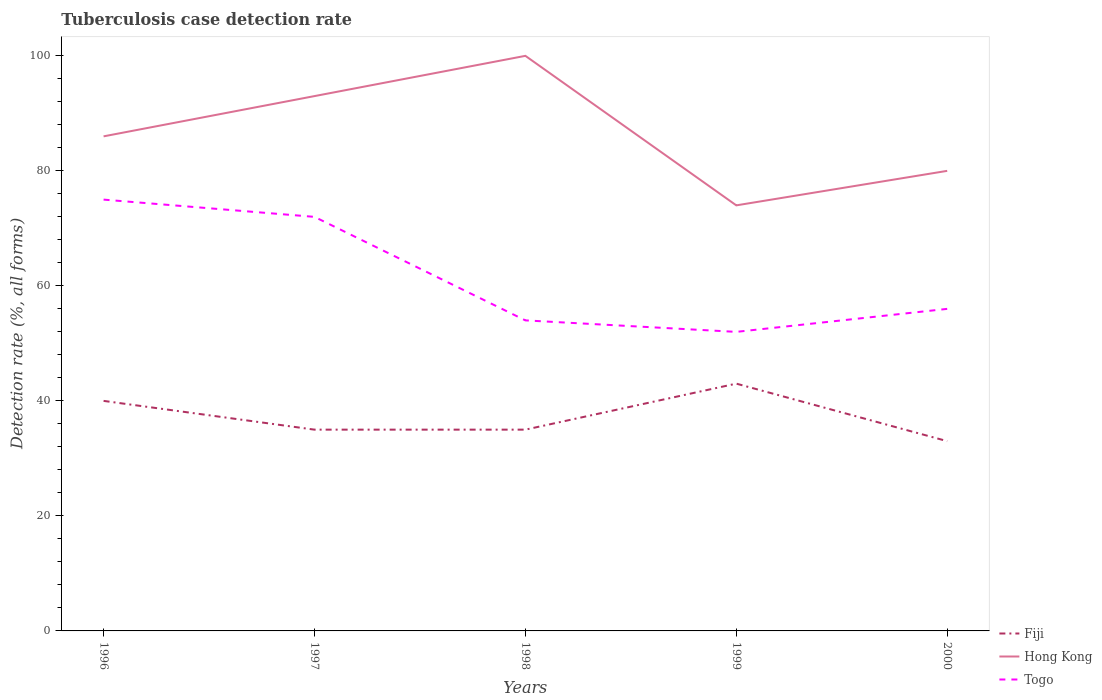How many different coloured lines are there?
Give a very brief answer. 3. Across all years, what is the maximum tuberculosis case detection rate in in Fiji?
Your answer should be very brief. 33. What is the difference between the highest and the lowest tuberculosis case detection rate in in Fiji?
Your answer should be compact. 2. Is the tuberculosis case detection rate in in Togo strictly greater than the tuberculosis case detection rate in in Hong Kong over the years?
Offer a very short reply. Yes. Are the values on the major ticks of Y-axis written in scientific E-notation?
Your answer should be very brief. No. Does the graph contain any zero values?
Your answer should be compact. No. Does the graph contain grids?
Offer a terse response. No. Where does the legend appear in the graph?
Ensure brevity in your answer.  Bottom right. What is the title of the graph?
Offer a terse response. Tuberculosis case detection rate. What is the label or title of the Y-axis?
Ensure brevity in your answer.  Detection rate (%, all forms). What is the Detection rate (%, all forms) in Hong Kong in 1996?
Your answer should be compact. 86. What is the Detection rate (%, all forms) in Fiji in 1997?
Offer a very short reply. 35. What is the Detection rate (%, all forms) in Hong Kong in 1997?
Your response must be concise. 93. What is the Detection rate (%, all forms) in Togo in 1997?
Your response must be concise. 72. What is the Detection rate (%, all forms) in Togo in 1999?
Keep it short and to the point. 52. What is the Detection rate (%, all forms) of Togo in 2000?
Provide a succinct answer. 56. Across all years, what is the maximum Detection rate (%, all forms) of Togo?
Offer a terse response. 75. Across all years, what is the minimum Detection rate (%, all forms) of Fiji?
Give a very brief answer. 33. Across all years, what is the minimum Detection rate (%, all forms) in Hong Kong?
Offer a terse response. 74. Across all years, what is the minimum Detection rate (%, all forms) in Togo?
Your response must be concise. 52. What is the total Detection rate (%, all forms) in Fiji in the graph?
Your answer should be compact. 186. What is the total Detection rate (%, all forms) of Hong Kong in the graph?
Keep it short and to the point. 433. What is the total Detection rate (%, all forms) in Togo in the graph?
Your answer should be very brief. 309. What is the difference between the Detection rate (%, all forms) in Fiji in 1996 and that in 1998?
Offer a terse response. 5. What is the difference between the Detection rate (%, all forms) in Hong Kong in 1996 and that in 1998?
Ensure brevity in your answer.  -14. What is the difference between the Detection rate (%, all forms) in Fiji in 1996 and that in 2000?
Provide a short and direct response. 7. What is the difference between the Detection rate (%, all forms) of Hong Kong in 1997 and that in 1998?
Provide a short and direct response. -7. What is the difference between the Detection rate (%, all forms) in Hong Kong in 1997 and that in 1999?
Your response must be concise. 19. What is the difference between the Detection rate (%, all forms) in Hong Kong in 1998 and that in 1999?
Your response must be concise. 26. What is the difference between the Detection rate (%, all forms) in Fiji in 1998 and that in 2000?
Your answer should be compact. 2. What is the difference between the Detection rate (%, all forms) in Hong Kong in 1998 and that in 2000?
Your answer should be compact. 20. What is the difference between the Detection rate (%, all forms) of Togo in 1999 and that in 2000?
Your response must be concise. -4. What is the difference between the Detection rate (%, all forms) of Fiji in 1996 and the Detection rate (%, all forms) of Hong Kong in 1997?
Your answer should be very brief. -53. What is the difference between the Detection rate (%, all forms) of Fiji in 1996 and the Detection rate (%, all forms) of Togo in 1997?
Provide a short and direct response. -32. What is the difference between the Detection rate (%, all forms) in Hong Kong in 1996 and the Detection rate (%, all forms) in Togo in 1997?
Provide a short and direct response. 14. What is the difference between the Detection rate (%, all forms) in Fiji in 1996 and the Detection rate (%, all forms) in Hong Kong in 1998?
Offer a very short reply. -60. What is the difference between the Detection rate (%, all forms) of Fiji in 1996 and the Detection rate (%, all forms) of Hong Kong in 1999?
Give a very brief answer. -34. What is the difference between the Detection rate (%, all forms) of Fiji in 1996 and the Detection rate (%, all forms) of Togo in 1999?
Provide a short and direct response. -12. What is the difference between the Detection rate (%, all forms) in Fiji in 1996 and the Detection rate (%, all forms) in Togo in 2000?
Offer a terse response. -16. What is the difference between the Detection rate (%, all forms) of Hong Kong in 1996 and the Detection rate (%, all forms) of Togo in 2000?
Provide a short and direct response. 30. What is the difference between the Detection rate (%, all forms) of Fiji in 1997 and the Detection rate (%, all forms) of Hong Kong in 1998?
Your response must be concise. -65. What is the difference between the Detection rate (%, all forms) of Fiji in 1997 and the Detection rate (%, all forms) of Togo in 1998?
Your response must be concise. -19. What is the difference between the Detection rate (%, all forms) of Hong Kong in 1997 and the Detection rate (%, all forms) of Togo in 1998?
Your answer should be very brief. 39. What is the difference between the Detection rate (%, all forms) in Fiji in 1997 and the Detection rate (%, all forms) in Hong Kong in 1999?
Make the answer very short. -39. What is the difference between the Detection rate (%, all forms) of Fiji in 1997 and the Detection rate (%, all forms) of Hong Kong in 2000?
Provide a succinct answer. -45. What is the difference between the Detection rate (%, all forms) of Fiji in 1997 and the Detection rate (%, all forms) of Togo in 2000?
Your answer should be compact. -21. What is the difference between the Detection rate (%, all forms) of Fiji in 1998 and the Detection rate (%, all forms) of Hong Kong in 1999?
Make the answer very short. -39. What is the difference between the Detection rate (%, all forms) of Hong Kong in 1998 and the Detection rate (%, all forms) of Togo in 1999?
Provide a short and direct response. 48. What is the difference between the Detection rate (%, all forms) of Fiji in 1998 and the Detection rate (%, all forms) of Hong Kong in 2000?
Your answer should be very brief. -45. What is the difference between the Detection rate (%, all forms) in Fiji in 1998 and the Detection rate (%, all forms) in Togo in 2000?
Offer a terse response. -21. What is the difference between the Detection rate (%, all forms) of Fiji in 1999 and the Detection rate (%, all forms) of Hong Kong in 2000?
Provide a succinct answer. -37. What is the difference between the Detection rate (%, all forms) in Fiji in 1999 and the Detection rate (%, all forms) in Togo in 2000?
Give a very brief answer. -13. What is the difference between the Detection rate (%, all forms) in Hong Kong in 1999 and the Detection rate (%, all forms) in Togo in 2000?
Ensure brevity in your answer.  18. What is the average Detection rate (%, all forms) of Fiji per year?
Your response must be concise. 37.2. What is the average Detection rate (%, all forms) of Hong Kong per year?
Keep it short and to the point. 86.6. What is the average Detection rate (%, all forms) of Togo per year?
Offer a very short reply. 61.8. In the year 1996, what is the difference between the Detection rate (%, all forms) of Fiji and Detection rate (%, all forms) of Hong Kong?
Provide a short and direct response. -46. In the year 1996, what is the difference between the Detection rate (%, all forms) of Fiji and Detection rate (%, all forms) of Togo?
Offer a terse response. -35. In the year 1996, what is the difference between the Detection rate (%, all forms) of Hong Kong and Detection rate (%, all forms) of Togo?
Offer a terse response. 11. In the year 1997, what is the difference between the Detection rate (%, all forms) of Fiji and Detection rate (%, all forms) of Hong Kong?
Provide a succinct answer. -58. In the year 1997, what is the difference between the Detection rate (%, all forms) in Fiji and Detection rate (%, all forms) in Togo?
Give a very brief answer. -37. In the year 1997, what is the difference between the Detection rate (%, all forms) in Hong Kong and Detection rate (%, all forms) in Togo?
Offer a terse response. 21. In the year 1998, what is the difference between the Detection rate (%, all forms) of Fiji and Detection rate (%, all forms) of Hong Kong?
Your response must be concise. -65. In the year 1998, what is the difference between the Detection rate (%, all forms) in Hong Kong and Detection rate (%, all forms) in Togo?
Give a very brief answer. 46. In the year 1999, what is the difference between the Detection rate (%, all forms) in Fiji and Detection rate (%, all forms) in Hong Kong?
Make the answer very short. -31. In the year 1999, what is the difference between the Detection rate (%, all forms) in Hong Kong and Detection rate (%, all forms) in Togo?
Offer a very short reply. 22. In the year 2000, what is the difference between the Detection rate (%, all forms) in Fiji and Detection rate (%, all forms) in Hong Kong?
Your answer should be very brief. -47. What is the ratio of the Detection rate (%, all forms) of Hong Kong in 1996 to that in 1997?
Your answer should be compact. 0.92. What is the ratio of the Detection rate (%, all forms) of Togo in 1996 to that in 1997?
Offer a very short reply. 1.04. What is the ratio of the Detection rate (%, all forms) of Fiji in 1996 to that in 1998?
Give a very brief answer. 1.14. What is the ratio of the Detection rate (%, all forms) of Hong Kong in 1996 to that in 1998?
Keep it short and to the point. 0.86. What is the ratio of the Detection rate (%, all forms) of Togo in 1996 to that in 1998?
Ensure brevity in your answer.  1.39. What is the ratio of the Detection rate (%, all forms) of Fiji in 1996 to that in 1999?
Provide a succinct answer. 0.93. What is the ratio of the Detection rate (%, all forms) of Hong Kong in 1996 to that in 1999?
Offer a very short reply. 1.16. What is the ratio of the Detection rate (%, all forms) of Togo in 1996 to that in 1999?
Make the answer very short. 1.44. What is the ratio of the Detection rate (%, all forms) in Fiji in 1996 to that in 2000?
Ensure brevity in your answer.  1.21. What is the ratio of the Detection rate (%, all forms) in Hong Kong in 1996 to that in 2000?
Provide a succinct answer. 1.07. What is the ratio of the Detection rate (%, all forms) of Togo in 1996 to that in 2000?
Make the answer very short. 1.34. What is the ratio of the Detection rate (%, all forms) of Fiji in 1997 to that in 1998?
Provide a short and direct response. 1. What is the ratio of the Detection rate (%, all forms) of Hong Kong in 1997 to that in 1998?
Offer a terse response. 0.93. What is the ratio of the Detection rate (%, all forms) in Togo in 1997 to that in 1998?
Make the answer very short. 1.33. What is the ratio of the Detection rate (%, all forms) of Fiji in 1997 to that in 1999?
Your answer should be very brief. 0.81. What is the ratio of the Detection rate (%, all forms) of Hong Kong in 1997 to that in 1999?
Keep it short and to the point. 1.26. What is the ratio of the Detection rate (%, all forms) of Togo in 1997 to that in 1999?
Provide a succinct answer. 1.38. What is the ratio of the Detection rate (%, all forms) of Fiji in 1997 to that in 2000?
Your answer should be very brief. 1.06. What is the ratio of the Detection rate (%, all forms) of Hong Kong in 1997 to that in 2000?
Offer a very short reply. 1.16. What is the ratio of the Detection rate (%, all forms) in Togo in 1997 to that in 2000?
Ensure brevity in your answer.  1.29. What is the ratio of the Detection rate (%, all forms) in Fiji in 1998 to that in 1999?
Keep it short and to the point. 0.81. What is the ratio of the Detection rate (%, all forms) of Hong Kong in 1998 to that in 1999?
Give a very brief answer. 1.35. What is the ratio of the Detection rate (%, all forms) of Fiji in 1998 to that in 2000?
Offer a very short reply. 1.06. What is the ratio of the Detection rate (%, all forms) in Fiji in 1999 to that in 2000?
Provide a short and direct response. 1.3. What is the ratio of the Detection rate (%, all forms) in Hong Kong in 1999 to that in 2000?
Offer a terse response. 0.93. What is the ratio of the Detection rate (%, all forms) of Togo in 1999 to that in 2000?
Provide a short and direct response. 0.93. What is the difference between the highest and the second highest Detection rate (%, all forms) of Fiji?
Give a very brief answer. 3. What is the difference between the highest and the lowest Detection rate (%, all forms) in Hong Kong?
Provide a short and direct response. 26. What is the difference between the highest and the lowest Detection rate (%, all forms) in Togo?
Give a very brief answer. 23. 